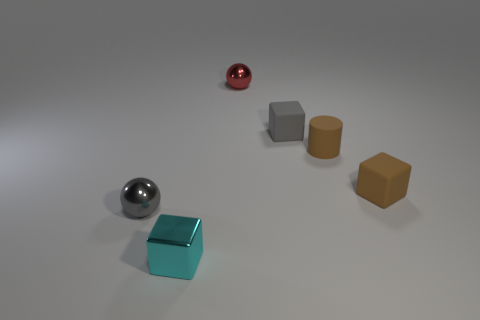Subtract all cyan metal blocks. How many blocks are left? 2 Add 3 cyan shiny cubes. How many objects exist? 9 Subtract all red balls. How many balls are left? 1 Subtract 2 blocks. How many blocks are left? 1 Subtract all cylinders. How many objects are left? 5 Subtract all brown cubes. How many gray balls are left? 1 Subtract all small gray objects. Subtract all small metallic cubes. How many objects are left? 3 Add 4 red objects. How many red objects are left? 5 Add 2 brown matte cylinders. How many brown matte cylinders exist? 3 Subtract 0 blue cubes. How many objects are left? 6 